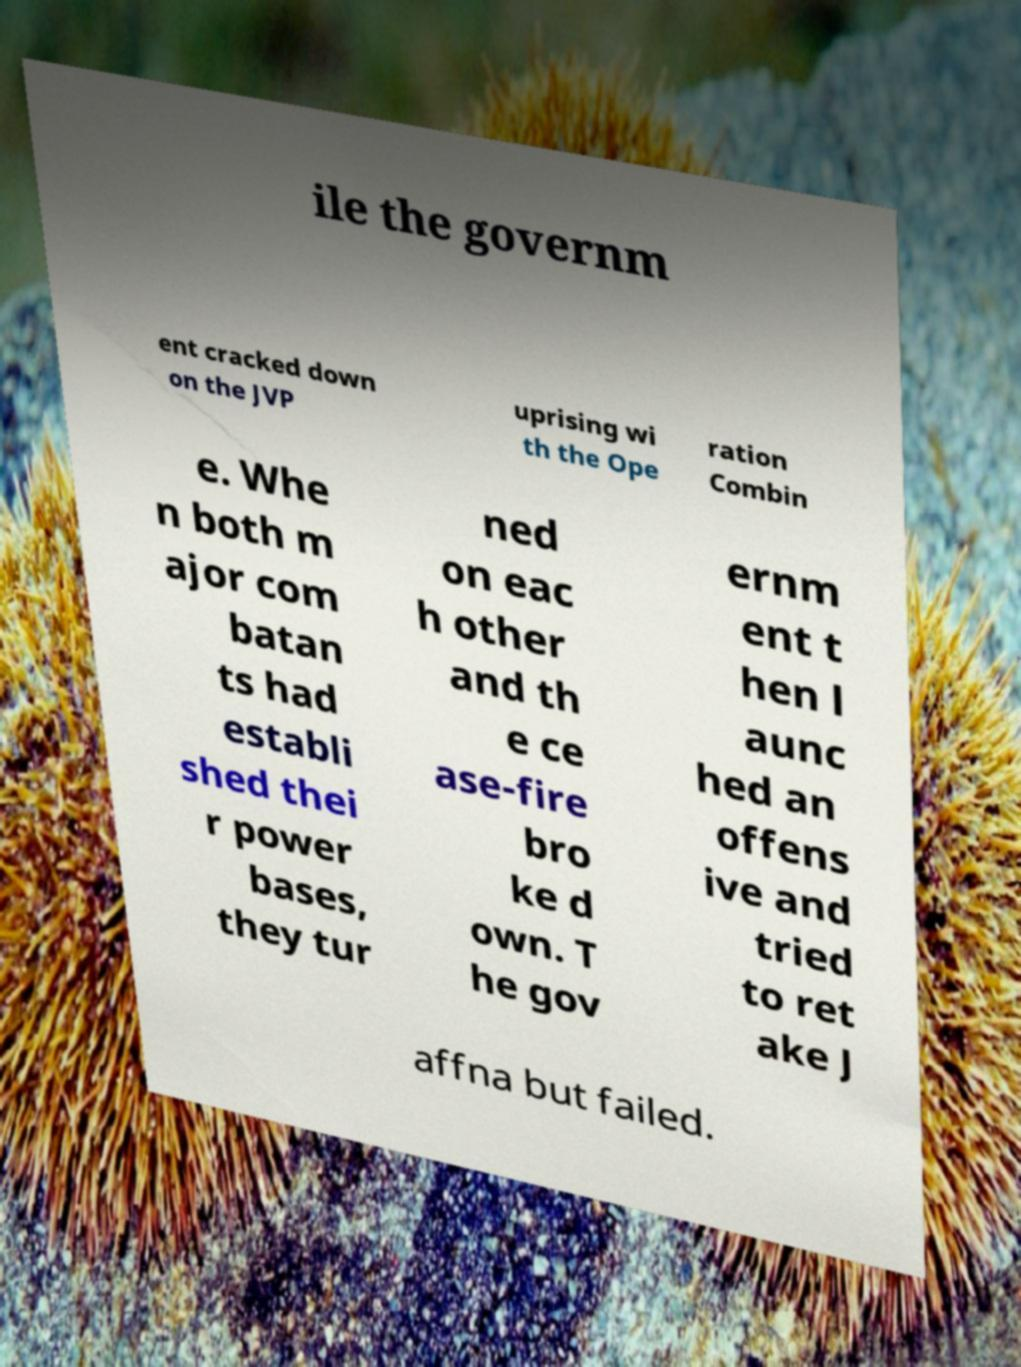Please read and relay the text visible in this image. What does it say? ile the governm ent cracked down on the JVP uprising wi th the Ope ration Combin e. Whe n both m ajor com batan ts had establi shed thei r power bases, they tur ned on eac h other and th e ce ase-fire bro ke d own. T he gov ernm ent t hen l aunc hed an offens ive and tried to ret ake J affna but failed. 